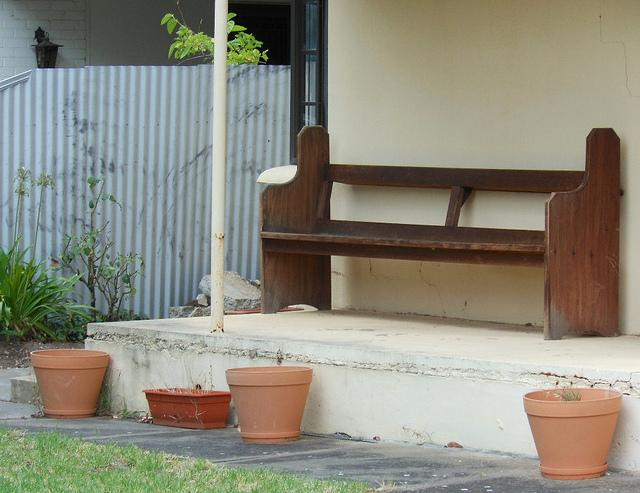What element is needed for the contents of the pots to extend their lives?

Choices:
A) cement
B) water
C) milk
D) juice water 